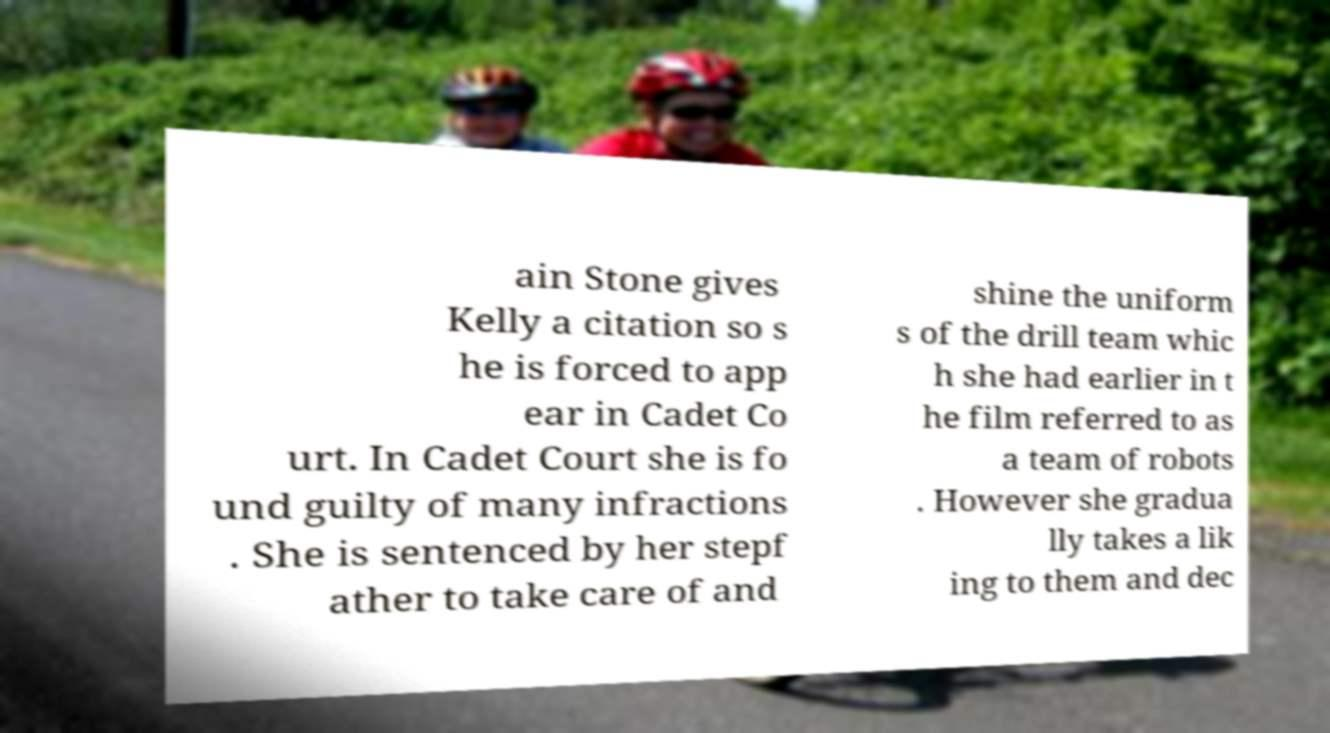Can you read and provide the text displayed in the image?This photo seems to have some interesting text. Can you extract and type it out for me? ain Stone gives Kelly a citation so s he is forced to app ear in Cadet Co urt. In Cadet Court she is fo und guilty of many infractions . She is sentenced by her stepf ather to take care of and shine the uniform s of the drill team whic h she had earlier in t he film referred to as a team of robots . However she gradua lly takes a lik ing to them and dec 